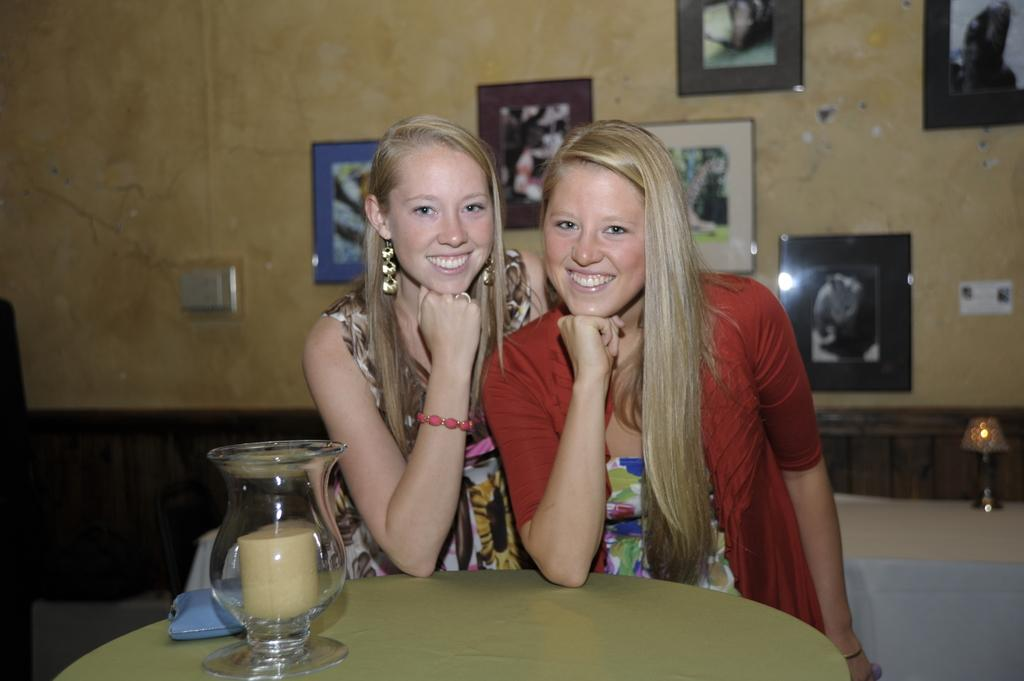How many people are in the image? There are two women in the image. What is the facial expression of the women? The women are smiling. What object can be seen on the table in the image? There is a candle on the table in the image. What type of decoration is on the wall in the image? There are photo frames on the wall in the image. What type of wool is being used to create the stage in the image? There is no wool or stage present in the image. How many cents are visible on the photo frames in the image? There are no cents visible on the photo frames in the image. 